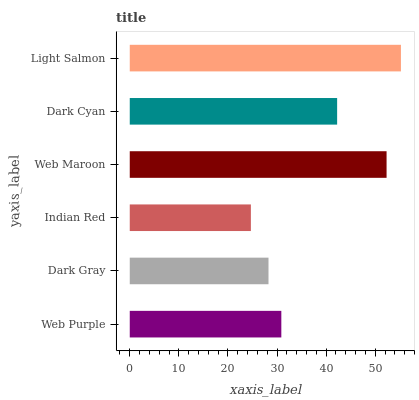Is Indian Red the minimum?
Answer yes or no. Yes. Is Light Salmon the maximum?
Answer yes or no. Yes. Is Dark Gray the minimum?
Answer yes or no. No. Is Dark Gray the maximum?
Answer yes or no. No. Is Web Purple greater than Dark Gray?
Answer yes or no. Yes. Is Dark Gray less than Web Purple?
Answer yes or no. Yes. Is Dark Gray greater than Web Purple?
Answer yes or no. No. Is Web Purple less than Dark Gray?
Answer yes or no. No. Is Dark Cyan the high median?
Answer yes or no. Yes. Is Web Purple the low median?
Answer yes or no. Yes. Is Web Purple the high median?
Answer yes or no. No. Is Dark Cyan the low median?
Answer yes or no. No. 